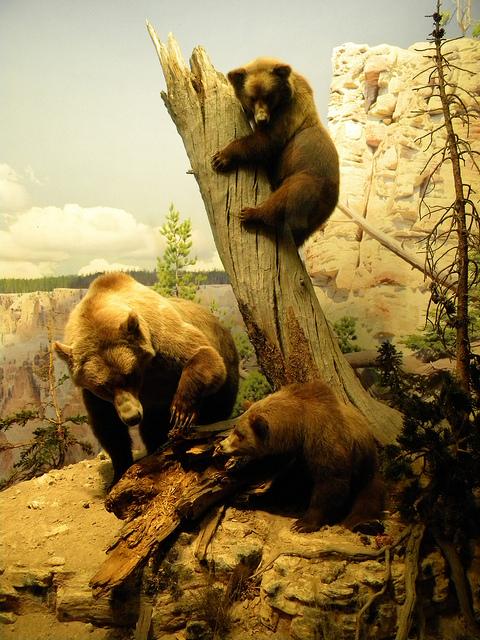What are the bears in?
Give a very brief answer. Tree. How many bears in the tree?
Give a very brief answer. 1. How many bears are in the photo?
Concise answer only. 3. What color are the bears?
Be succinct. Brown. How many animals are shown?
Be succinct. 3. Where is this?
Be succinct. Museum. What color is this animal?
Give a very brief answer. Brown. How many claws on the bear are visible?
Write a very short answer. 5. Are the bears relaxing?
Keep it brief. Yes. Is the bear white or yellow?
Answer briefly. Brown. What is the bear on the left doing?
Write a very short answer. Walking. What type of bears are these?
Concise answer only. Grizzly. 